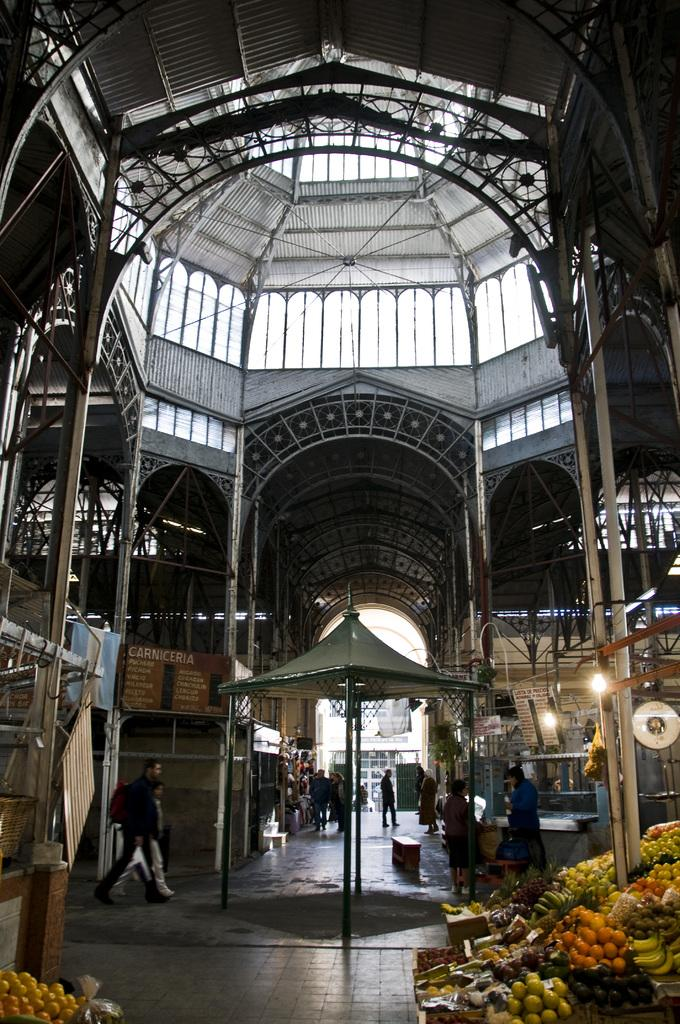What is the setting of the image? The image shows the inside of a building. What are the people in the image doing? There are people walking inside the building. Can you describe any objects or items in the image? Yes, there are fruits placed in the image. How much wealth is displayed in the image? There is no indication of wealth in the image; it only shows people walking and fruits placed in the scene. What type of cable can be seen connecting the tomatoes in the image? There are no tomatoes or cables present in the image. 